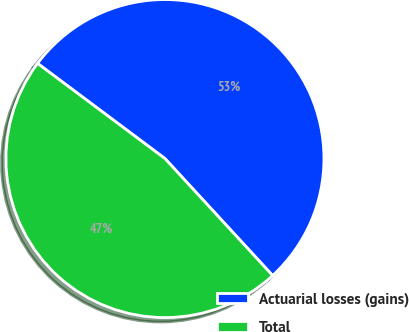<chart> <loc_0><loc_0><loc_500><loc_500><pie_chart><fcel>Actuarial losses (gains)<fcel>Total<nl><fcel>52.95%<fcel>47.05%<nl></chart> 